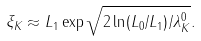Convert formula to latex. <formula><loc_0><loc_0><loc_500><loc_500>\xi _ { K } \approx L _ { 1 } \exp \sqrt { 2 \ln ( L _ { 0 } / L _ { 1 } ) / \lambda _ { K } ^ { 0 } } .</formula> 